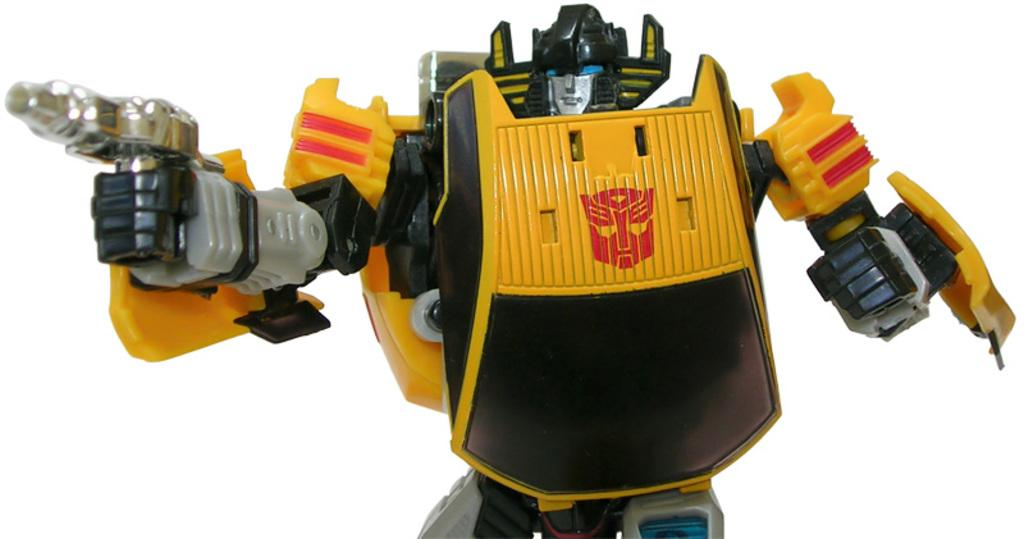What type of toy is present in the image? There is a toy robot in the image. Can you describe the toy in more detail? The toy robot is the main subject of the image. What is the toy robot doing in the image? The image does not show the toy robot in action, so it is not possible to determine what it is doing. What type of bomb is the toy robot holding in the image? There is no bomb present in the image; it is a toy robot, not a weapon. How does the toy robot show respect in the image? The image does not depict the toy robot showing respect, as it is a toy and not capable of expressing emotions or social behaviors. 